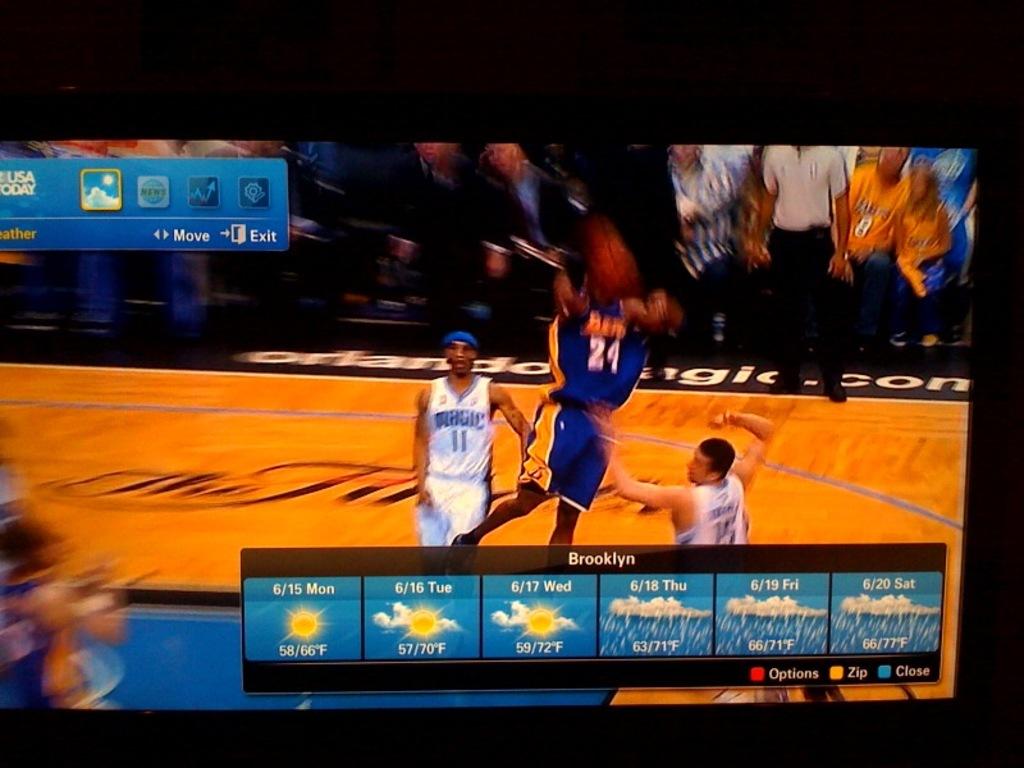What will the low be on 6/17 in brooklyn?
Ensure brevity in your answer.  59. What city is this weather forecast for?
Offer a terse response. Brooklyn. 